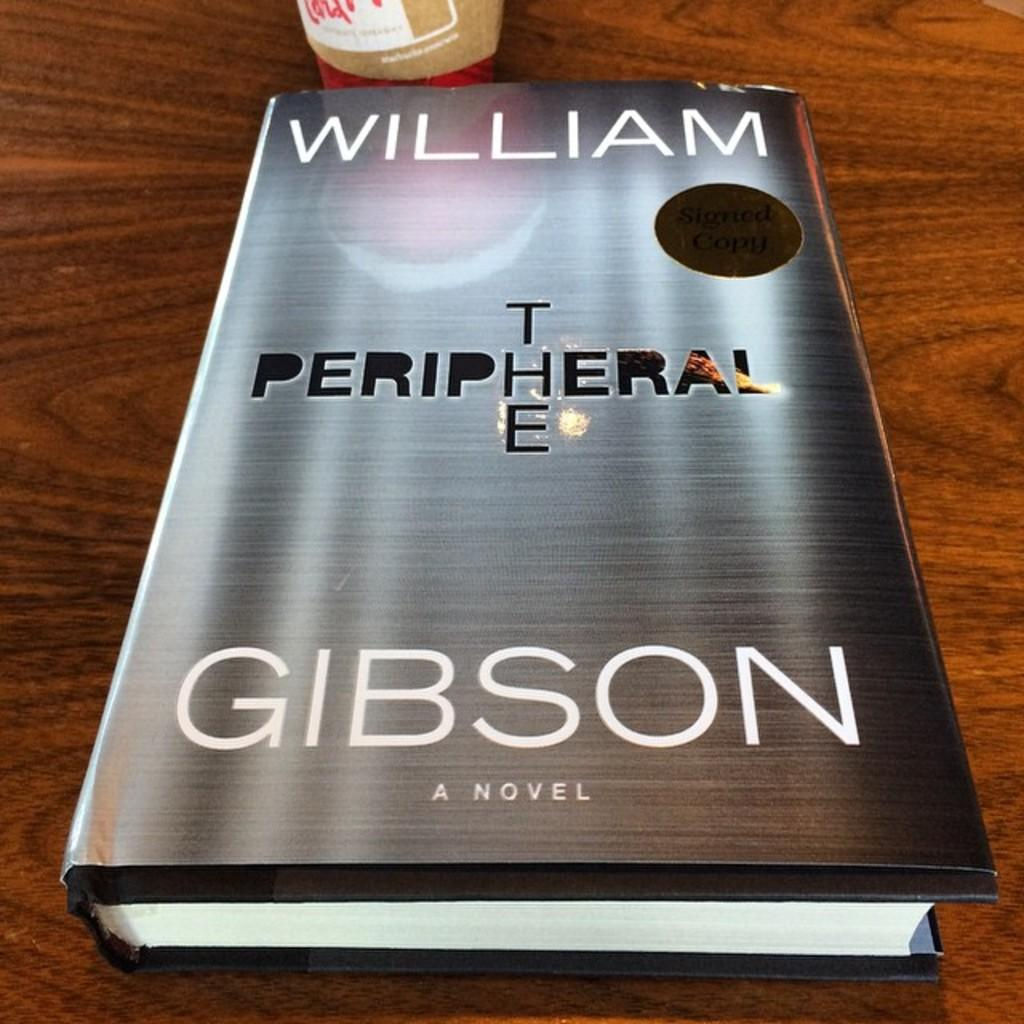<image>
Give a short and clear explanation of the subsequent image. A novel by William Gibson sits on a wooden table. 